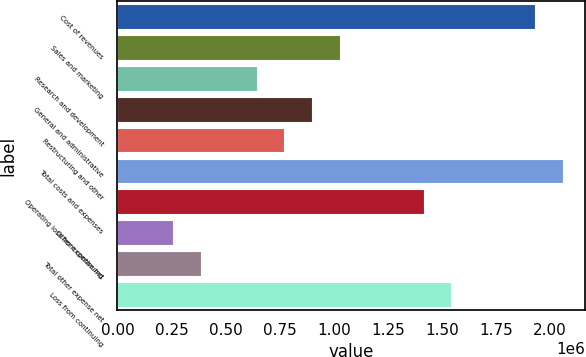Convert chart. <chart><loc_0><loc_0><loc_500><loc_500><bar_chart><fcel>Cost of revenues<fcel>Sales and marketing<fcel>Research and development<fcel>General and administrative<fcel>Restructuring and other<fcel>Total costs and expenses<fcel>Operating loss from continuing<fcel>Other expense net<fcel>Total other expense net<fcel>Loss from continuing<nl><fcel>1.92974e+06<fcel>1.02919e+06<fcel>643245<fcel>900543<fcel>771894<fcel>2.05838e+06<fcel>1.41514e+06<fcel>257298<fcel>385947<fcel>1.54379e+06<nl></chart> 